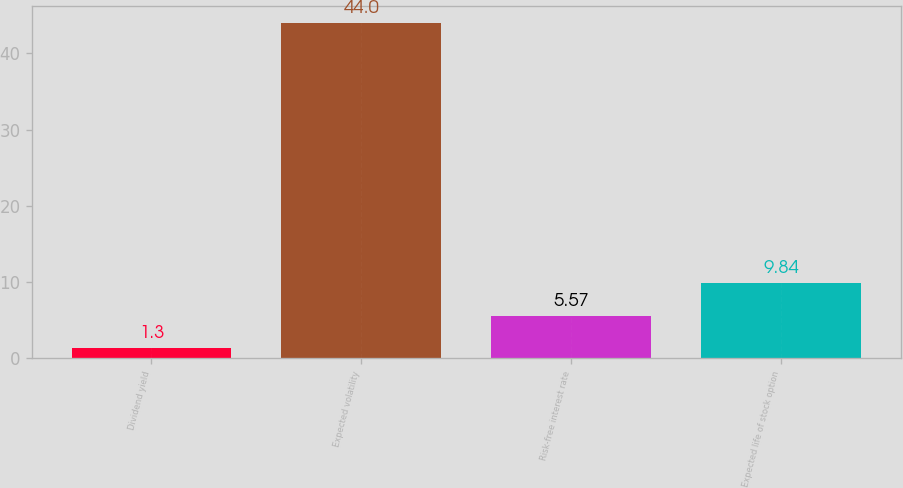Convert chart to OTSL. <chart><loc_0><loc_0><loc_500><loc_500><bar_chart><fcel>Dividend yield<fcel>Expected volatility<fcel>Risk-free interest rate<fcel>Expected life of stock option<nl><fcel>1.3<fcel>44<fcel>5.57<fcel>9.84<nl></chart> 